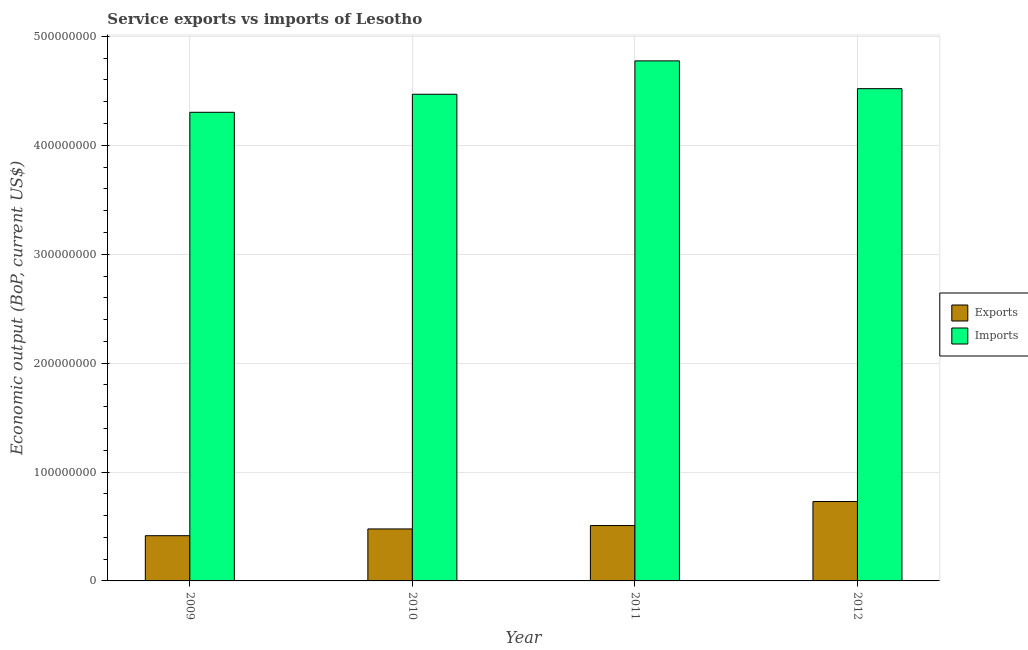How many different coloured bars are there?
Keep it short and to the point. 2. How many bars are there on the 2nd tick from the left?
Your answer should be compact. 2. How many bars are there on the 1st tick from the right?
Offer a terse response. 2. What is the amount of service imports in 2009?
Keep it short and to the point. 4.30e+08. Across all years, what is the maximum amount of service exports?
Your answer should be compact. 7.29e+07. Across all years, what is the minimum amount of service imports?
Offer a terse response. 4.30e+08. What is the total amount of service exports in the graph?
Your answer should be very brief. 2.13e+08. What is the difference between the amount of service imports in 2010 and that in 2012?
Provide a succinct answer. -5.14e+06. What is the difference between the amount of service imports in 2012 and the amount of service exports in 2011?
Provide a succinct answer. -2.55e+07. What is the average amount of service exports per year?
Offer a very short reply. 5.33e+07. In the year 2012, what is the difference between the amount of service imports and amount of service exports?
Ensure brevity in your answer.  0. In how many years, is the amount of service imports greater than 100000000 US$?
Keep it short and to the point. 4. What is the ratio of the amount of service exports in 2011 to that in 2012?
Your answer should be very brief. 0.7. Is the difference between the amount of service exports in 2010 and 2012 greater than the difference between the amount of service imports in 2010 and 2012?
Give a very brief answer. No. What is the difference between the highest and the second highest amount of service imports?
Ensure brevity in your answer.  2.55e+07. What is the difference between the highest and the lowest amount of service imports?
Provide a succinct answer. 4.72e+07. In how many years, is the amount of service imports greater than the average amount of service imports taken over all years?
Provide a short and direct response. 2. What does the 2nd bar from the left in 2011 represents?
Provide a short and direct response. Imports. What does the 1st bar from the right in 2012 represents?
Provide a short and direct response. Imports. How many years are there in the graph?
Keep it short and to the point. 4. Are the values on the major ticks of Y-axis written in scientific E-notation?
Make the answer very short. No. Does the graph contain any zero values?
Your response must be concise. No. Does the graph contain grids?
Give a very brief answer. Yes. How many legend labels are there?
Your answer should be compact. 2. What is the title of the graph?
Give a very brief answer. Service exports vs imports of Lesotho. Does "Female entrants" appear as one of the legend labels in the graph?
Your answer should be very brief. No. What is the label or title of the X-axis?
Provide a succinct answer. Year. What is the label or title of the Y-axis?
Give a very brief answer. Economic output (BoP, current US$). What is the Economic output (BoP, current US$) of Exports in 2009?
Provide a short and direct response. 4.15e+07. What is the Economic output (BoP, current US$) in Imports in 2009?
Offer a very short reply. 4.30e+08. What is the Economic output (BoP, current US$) of Exports in 2010?
Keep it short and to the point. 4.77e+07. What is the Economic output (BoP, current US$) in Imports in 2010?
Keep it short and to the point. 4.47e+08. What is the Economic output (BoP, current US$) of Exports in 2011?
Offer a terse response. 5.08e+07. What is the Economic output (BoP, current US$) of Imports in 2011?
Ensure brevity in your answer.  4.78e+08. What is the Economic output (BoP, current US$) of Exports in 2012?
Give a very brief answer. 7.29e+07. What is the Economic output (BoP, current US$) of Imports in 2012?
Offer a very short reply. 4.52e+08. Across all years, what is the maximum Economic output (BoP, current US$) in Exports?
Give a very brief answer. 7.29e+07. Across all years, what is the maximum Economic output (BoP, current US$) of Imports?
Keep it short and to the point. 4.78e+08. Across all years, what is the minimum Economic output (BoP, current US$) of Exports?
Your response must be concise. 4.15e+07. Across all years, what is the minimum Economic output (BoP, current US$) in Imports?
Offer a very short reply. 4.30e+08. What is the total Economic output (BoP, current US$) in Exports in the graph?
Offer a terse response. 2.13e+08. What is the total Economic output (BoP, current US$) of Imports in the graph?
Your answer should be compact. 1.81e+09. What is the difference between the Economic output (BoP, current US$) in Exports in 2009 and that in 2010?
Keep it short and to the point. -6.19e+06. What is the difference between the Economic output (BoP, current US$) of Imports in 2009 and that in 2010?
Make the answer very short. -1.66e+07. What is the difference between the Economic output (BoP, current US$) of Exports in 2009 and that in 2011?
Provide a short and direct response. -9.29e+06. What is the difference between the Economic output (BoP, current US$) of Imports in 2009 and that in 2011?
Offer a terse response. -4.72e+07. What is the difference between the Economic output (BoP, current US$) of Exports in 2009 and that in 2012?
Ensure brevity in your answer.  -3.14e+07. What is the difference between the Economic output (BoP, current US$) of Imports in 2009 and that in 2012?
Your answer should be compact. -2.17e+07. What is the difference between the Economic output (BoP, current US$) in Exports in 2010 and that in 2011?
Provide a succinct answer. -3.10e+06. What is the difference between the Economic output (BoP, current US$) of Imports in 2010 and that in 2011?
Provide a succinct answer. -3.07e+07. What is the difference between the Economic output (BoP, current US$) of Exports in 2010 and that in 2012?
Your response must be concise. -2.52e+07. What is the difference between the Economic output (BoP, current US$) of Imports in 2010 and that in 2012?
Give a very brief answer. -5.14e+06. What is the difference between the Economic output (BoP, current US$) in Exports in 2011 and that in 2012?
Ensure brevity in your answer.  -2.21e+07. What is the difference between the Economic output (BoP, current US$) in Imports in 2011 and that in 2012?
Ensure brevity in your answer.  2.55e+07. What is the difference between the Economic output (BoP, current US$) in Exports in 2009 and the Economic output (BoP, current US$) in Imports in 2010?
Your answer should be compact. -4.05e+08. What is the difference between the Economic output (BoP, current US$) of Exports in 2009 and the Economic output (BoP, current US$) of Imports in 2011?
Provide a succinct answer. -4.36e+08. What is the difference between the Economic output (BoP, current US$) in Exports in 2009 and the Economic output (BoP, current US$) in Imports in 2012?
Offer a very short reply. -4.10e+08. What is the difference between the Economic output (BoP, current US$) of Exports in 2010 and the Economic output (BoP, current US$) of Imports in 2011?
Ensure brevity in your answer.  -4.30e+08. What is the difference between the Economic output (BoP, current US$) of Exports in 2010 and the Economic output (BoP, current US$) of Imports in 2012?
Provide a succinct answer. -4.04e+08. What is the difference between the Economic output (BoP, current US$) of Exports in 2011 and the Economic output (BoP, current US$) of Imports in 2012?
Provide a succinct answer. -4.01e+08. What is the average Economic output (BoP, current US$) in Exports per year?
Give a very brief answer. 5.33e+07. What is the average Economic output (BoP, current US$) of Imports per year?
Provide a short and direct response. 4.52e+08. In the year 2009, what is the difference between the Economic output (BoP, current US$) of Exports and Economic output (BoP, current US$) of Imports?
Offer a terse response. -3.89e+08. In the year 2010, what is the difference between the Economic output (BoP, current US$) of Exports and Economic output (BoP, current US$) of Imports?
Make the answer very short. -3.99e+08. In the year 2011, what is the difference between the Economic output (BoP, current US$) of Exports and Economic output (BoP, current US$) of Imports?
Offer a terse response. -4.27e+08. In the year 2012, what is the difference between the Economic output (BoP, current US$) in Exports and Economic output (BoP, current US$) in Imports?
Give a very brief answer. -3.79e+08. What is the ratio of the Economic output (BoP, current US$) in Exports in 2009 to that in 2010?
Keep it short and to the point. 0.87. What is the ratio of the Economic output (BoP, current US$) in Exports in 2009 to that in 2011?
Make the answer very short. 0.82. What is the ratio of the Economic output (BoP, current US$) in Imports in 2009 to that in 2011?
Keep it short and to the point. 0.9. What is the ratio of the Economic output (BoP, current US$) in Exports in 2009 to that in 2012?
Keep it short and to the point. 0.57. What is the ratio of the Economic output (BoP, current US$) of Imports in 2009 to that in 2012?
Ensure brevity in your answer.  0.95. What is the ratio of the Economic output (BoP, current US$) of Exports in 2010 to that in 2011?
Provide a succinct answer. 0.94. What is the ratio of the Economic output (BoP, current US$) in Imports in 2010 to that in 2011?
Offer a very short reply. 0.94. What is the ratio of the Economic output (BoP, current US$) of Exports in 2010 to that in 2012?
Make the answer very short. 0.65. What is the ratio of the Economic output (BoP, current US$) in Imports in 2010 to that in 2012?
Ensure brevity in your answer.  0.99. What is the ratio of the Economic output (BoP, current US$) in Exports in 2011 to that in 2012?
Ensure brevity in your answer.  0.7. What is the ratio of the Economic output (BoP, current US$) in Imports in 2011 to that in 2012?
Keep it short and to the point. 1.06. What is the difference between the highest and the second highest Economic output (BoP, current US$) of Exports?
Make the answer very short. 2.21e+07. What is the difference between the highest and the second highest Economic output (BoP, current US$) of Imports?
Your answer should be compact. 2.55e+07. What is the difference between the highest and the lowest Economic output (BoP, current US$) in Exports?
Your answer should be compact. 3.14e+07. What is the difference between the highest and the lowest Economic output (BoP, current US$) of Imports?
Your answer should be compact. 4.72e+07. 